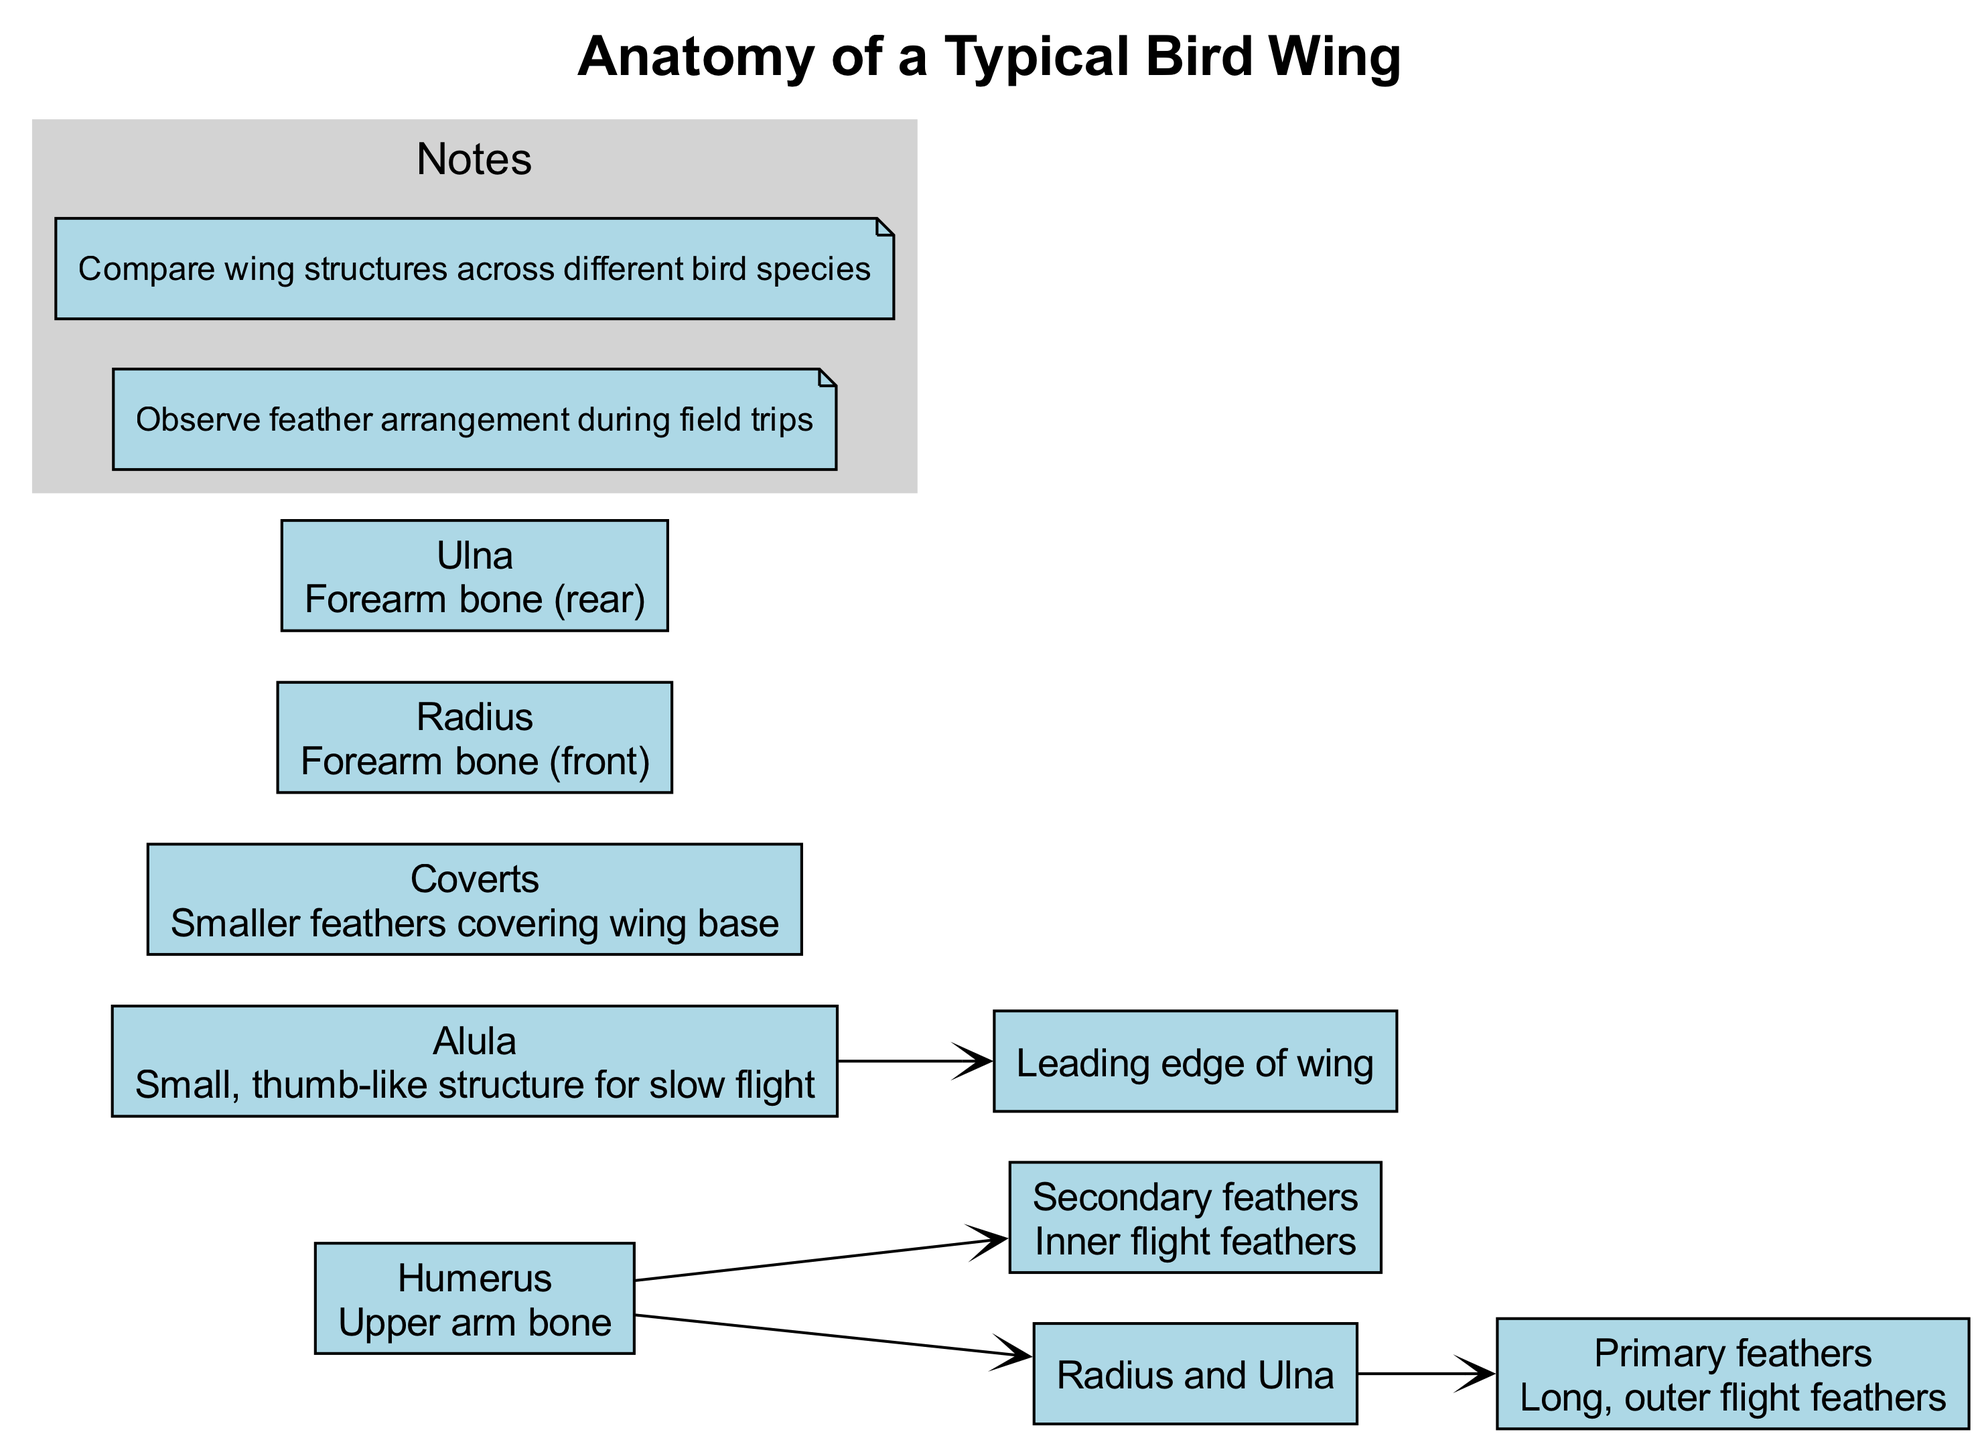What are the long, outer flight feathers called? The diagram labels the long, outer flight feathers as "Primary feathers" in the section describing the main components.
Answer: Primary feathers How many main components are listed in the diagram? Counting the items under main components, there are seven listed: Primary feathers, Secondary feathers, Alula, Coverts, Humerus, Radius, and Ulna.
Answer: 7 What is the function of the Alula? The diagram states that the Alula is a small, thumb-like structure used for slow flight, which indicates its functional role.
Answer: Slow flight Which bone connects to both the Radius and Ulna? The diagram shows that the Humerus connects to both the Radius and Ulna, indicating its role as the upper arm bone.
Answer: Humerus What type of feathers are the Secondary feathers? According to the diagram, Secondary feathers are described as "Inner flight feathers," which defines their type and location on the wing.
Answer: Inner flight feathers How does the Humerus relate to the feathers? The diagram indicates that the Humerus connects to the Secondary feathers directly, demonstrating that it supports the inner flight feathers.
Answer: Connects to Secondary feathers What component is designed for handling the leading edge of the wing? The diagram specifies that the Alula has a connection to the leading edge of the wing, indicating its structural importance there.
Answer: Alula Which part of the wing structure is covered by the Coverts? The Coverts are described in the diagram as smaller feathers covering the wing base, indicating their position related to the overall wing structure.
Answer: Wing base 